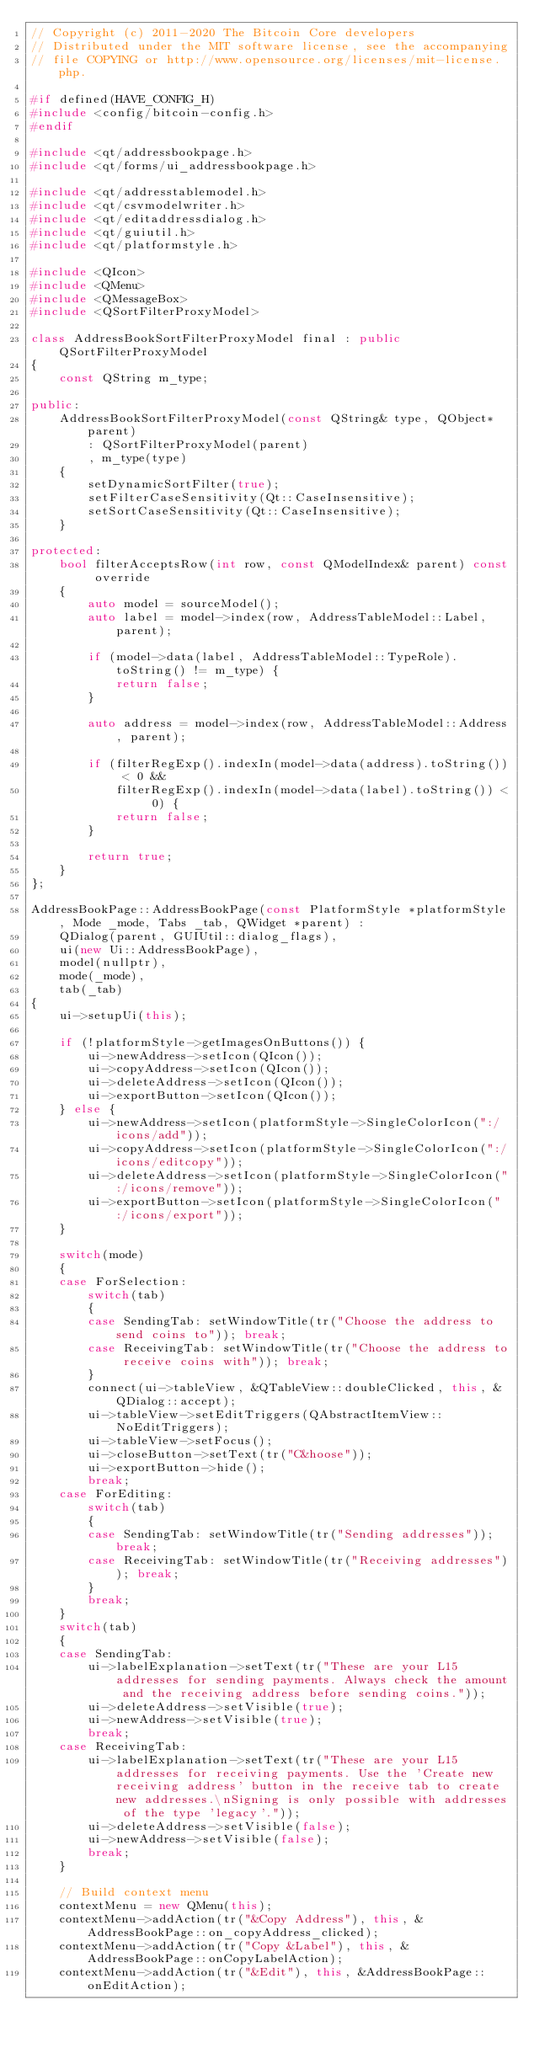<code> <loc_0><loc_0><loc_500><loc_500><_C++_>// Copyright (c) 2011-2020 The Bitcoin Core developers
// Distributed under the MIT software license, see the accompanying
// file COPYING or http://www.opensource.org/licenses/mit-license.php.

#if defined(HAVE_CONFIG_H)
#include <config/bitcoin-config.h>
#endif

#include <qt/addressbookpage.h>
#include <qt/forms/ui_addressbookpage.h>

#include <qt/addresstablemodel.h>
#include <qt/csvmodelwriter.h>
#include <qt/editaddressdialog.h>
#include <qt/guiutil.h>
#include <qt/platformstyle.h>

#include <QIcon>
#include <QMenu>
#include <QMessageBox>
#include <QSortFilterProxyModel>

class AddressBookSortFilterProxyModel final : public QSortFilterProxyModel
{
    const QString m_type;

public:
    AddressBookSortFilterProxyModel(const QString& type, QObject* parent)
        : QSortFilterProxyModel(parent)
        , m_type(type)
    {
        setDynamicSortFilter(true);
        setFilterCaseSensitivity(Qt::CaseInsensitive);
        setSortCaseSensitivity(Qt::CaseInsensitive);
    }

protected:
    bool filterAcceptsRow(int row, const QModelIndex& parent) const override
    {
        auto model = sourceModel();
        auto label = model->index(row, AddressTableModel::Label, parent);

        if (model->data(label, AddressTableModel::TypeRole).toString() != m_type) {
            return false;
        }

        auto address = model->index(row, AddressTableModel::Address, parent);

        if (filterRegExp().indexIn(model->data(address).toString()) < 0 &&
            filterRegExp().indexIn(model->data(label).toString()) < 0) {
            return false;
        }

        return true;
    }
};

AddressBookPage::AddressBookPage(const PlatformStyle *platformStyle, Mode _mode, Tabs _tab, QWidget *parent) :
    QDialog(parent, GUIUtil::dialog_flags),
    ui(new Ui::AddressBookPage),
    model(nullptr),
    mode(_mode),
    tab(_tab)
{
    ui->setupUi(this);

    if (!platformStyle->getImagesOnButtons()) {
        ui->newAddress->setIcon(QIcon());
        ui->copyAddress->setIcon(QIcon());
        ui->deleteAddress->setIcon(QIcon());
        ui->exportButton->setIcon(QIcon());
    } else {
        ui->newAddress->setIcon(platformStyle->SingleColorIcon(":/icons/add"));
        ui->copyAddress->setIcon(platformStyle->SingleColorIcon(":/icons/editcopy"));
        ui->deleteAddress->setIcon(platformStyle->SingleColorIcon(":/icons/remove"));
        ui->exportButton->setIcon(platformStyle->SingleColorIcon(":/icons/export"));
    }

    switch(mode)
    {
    case ForSelection:
        switch(tab)
        {
        case SendingTab: setWindowTitle(tr("Choose the address to send coins to")); break;
        case ReceivingTab: setWindowTitle(tr("Choose the address to receive coins with")); break;
        }
        connect(ui->tableView, &QTableView::doubleClicked, this, &QDialog::accept);
        ui->tableView->setEditTriggers(QAbstractItemView::NoEditTriggers);
        ui->tableView->setFocus();
        ui->closeButton->setText(tr("C&hoose"));
        ui->exportButton->hide();
        break;
    case ForEditing:
        switch(tab)
        {
        case SendingTab: setWindowTitle(tr("Sending addresses")); break;
        case ReceivingTab: setWindowTitle(tr("Receiving addresses")); break;
        }
        break;
    }
    switch(tab)
    {
    case SendingTab:
        ui->labelExplanation->setText(tr("These are your L15 addresses for sending payments. Always check the amount and the receiving address before sending coins."));
        ui->deleteAddress->setVisible(true);
        ui->newAddress->setVisible(true);
        break;
    case ReceivingTab:
        ui->labelExplanation->setText(tr("These are your L15 addresses for receiving payments. Use the 'Create new receiving address' button in the receive tab to create new addresses.\nSigning is only possible with addresses of the type 'legacy'."));
        ui->deleteAddress->setVisible(false);
        ui->newAddress->setVisible(false);
        break;
    }

    // Build context menu
    contextMenu = new QMenu(this);
    contextMenu->addAction(tr("&Copy Address"), this, &AddressBookPage::on_copyAddress_clicked);
    contextMenu->addAction(tr("Copy &Label"), this, &AddressBookPage::onCopyLabelAction);
    contextMenu->addAction(tr("&Edit"), this, &AddressBookPage::onEditAction);
</code> 